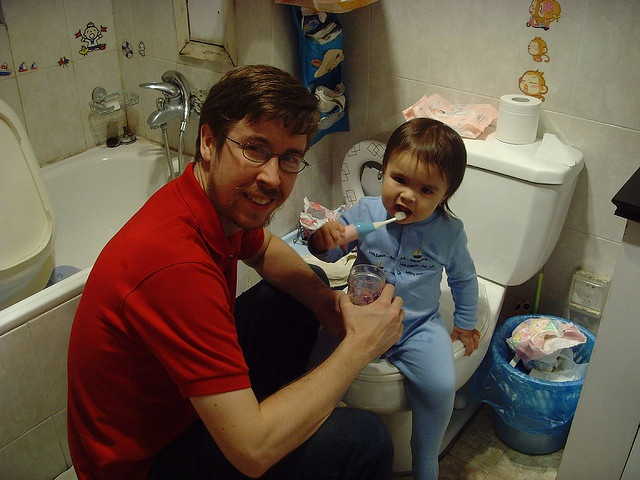Describe the objects in this image and their specific colors. I can see people in black, maroon, and olive tones, toilet in black, darkgray, gray, and blue tones, people in black, gray, blue, and maroon tones, sink in black, darkgray, gray, and olive tones, and cup in black, gray, and maroon tones in this image. 